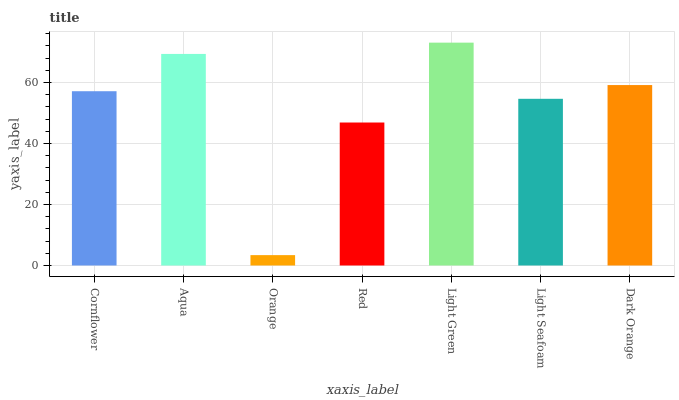Is Orange the minimum?
Answer yes or no. Yes. Is Light Green the maximum?
Answer yes or no. Yes. Is Aqua the minimum?
Answer yes or no. No. Is Aqua the maximum?
Answer yes or no. No. Is Aqua greater than Cornflower?
Answer yes or no. Yes. Is Cornflower less than Aqua?
Answer yes or no. Yes. Is Cornflower greater than Aqua?
Answer yes or no. No. Is Aqua less than Cornflower?
Answer yes or no. No. Is Cornflower the high median?
Answer yes or no. Yes. Is Cornflower the low median?
Answer yes or no. Yes. Is Light Green the high median?
Answer yes or no. No. Is Light Green the low median?
Answer yes or no. No. 